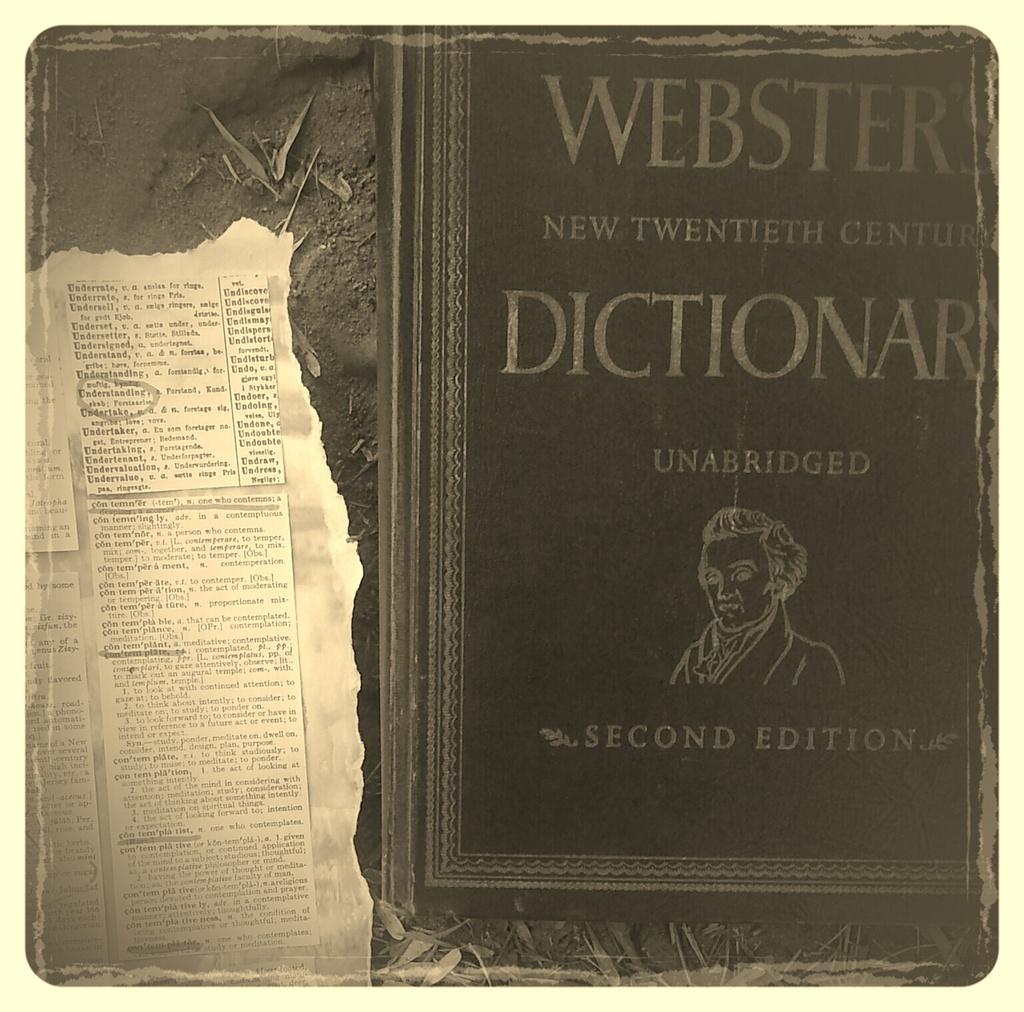What kind of book is this?
Provide a short and direct response. Dictionary. What century is this from?\?
Provide a short and direct response. Twentieth. 